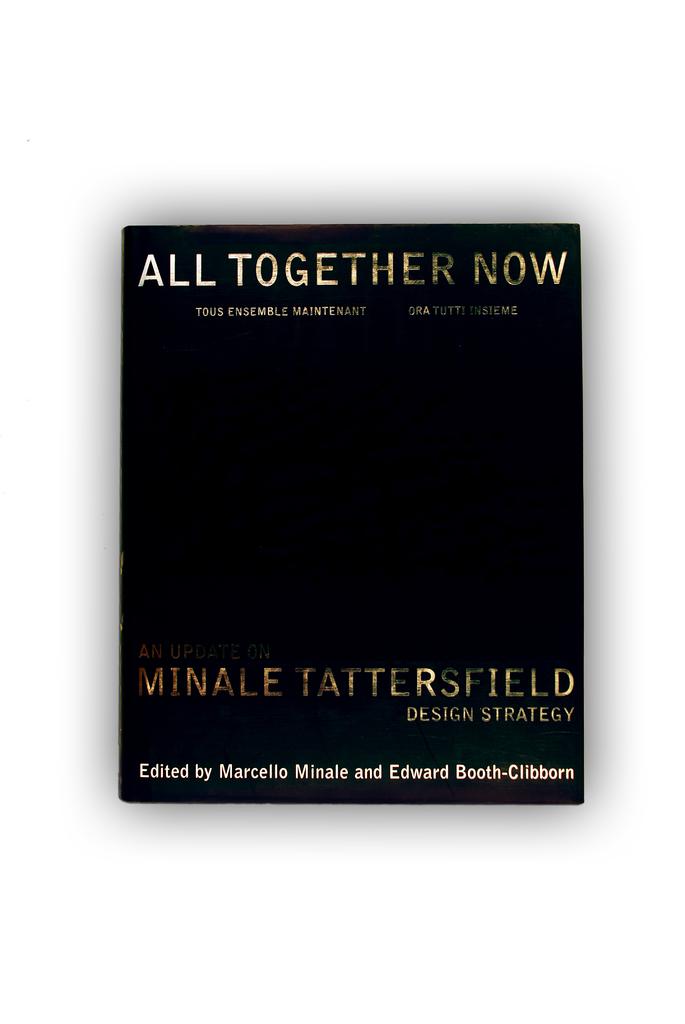Who is the author of the book?
Ensure brevity in your answer.  Minale tattersfield. 